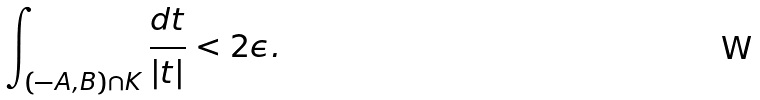Convert formula to latex. <formula><loc_0><loc_0><loc_500><loc_500>\int _ { ( - A , B ) \cap K } \frac { d t } { | t | } < 2 \epsilon .</formula> 